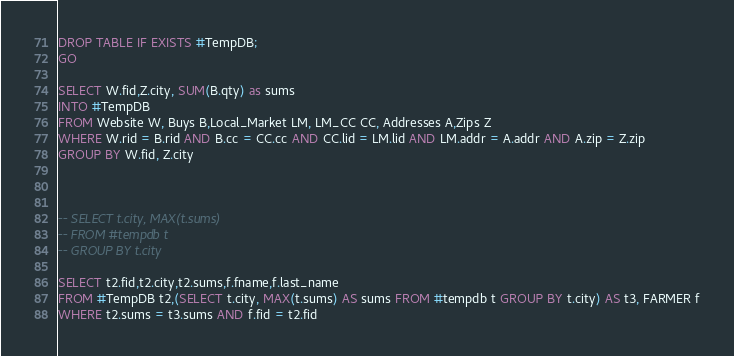<code> <loc_0><loc_0><loc_500><loc_500><_SQL_>DROP TABLE IF EXISTS #TempDB;
GO

SELECT W.fid,Z.city, SUM(B.qty) as sums
INTO #TempDB
FROM Website W, Buys B,Local_Market LM, LM_CC CC, Addresses A,Zips Z
WHERE W.rid = B.rid AND B.cc = CC.cc AND CC.lid = LM.lid AND LM.addr = A.addr AND A.zip = Z.zip
GROUP BY W.fid, Z.city



-- SELECT t.city, MAX(t.sums)
-- FROM #tempdb t
-- GROUP BY t.city

SELECT t2.fid,t2.city,t2.sums,f.fname,f.last_name
FROM #TempDB t2,(SELECT t.city, MAX(t.sums) AS sums FROM #tempdb t GROUP BY t.city) AS t3, FARMER f
WHERE t2.sums = t3.sums AND f.fid = t2.fid</code> 